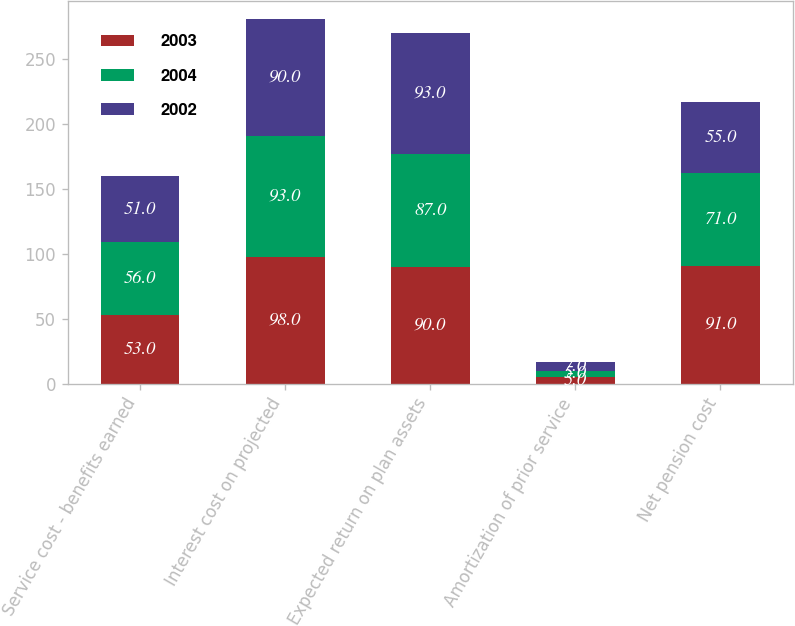<chart> <loc_0><loc_0><loc_500><loc_500><stacked_bar_chart><ecel><fcel>Service cost - benefits earned<fcel>Interest cost on projected<fcel>Expected return on plan assets<fcel>Amortization of prior service<fcel>Net pension cost<nl><fcel>2003<fcel>53<fcel>98<fcel>90<fcel>5<fcel>91<nl><fcel>2004<fcel>56<fcel>93<fcel>87<fcel>5<fcel>71<nl><fcel>2002<fcel>51<fcel>90<fcel>93<fcel>7<fcel>55<nl></chart> 